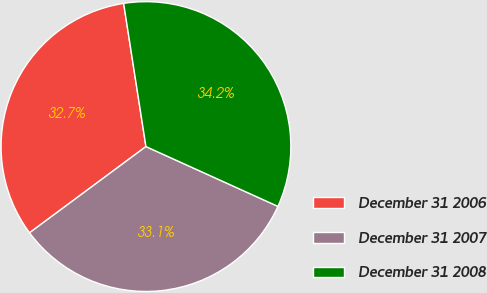Convert chart. <chart><loc_0><loc_0><loc_500><loc_500><pie_chart><fcel>December 31 2006<fcel>December 31 2007<fcel>December 31 2008<nl><fcel>32.69%<fcel>33.08%<fcel>34.23%<nl></chart> 